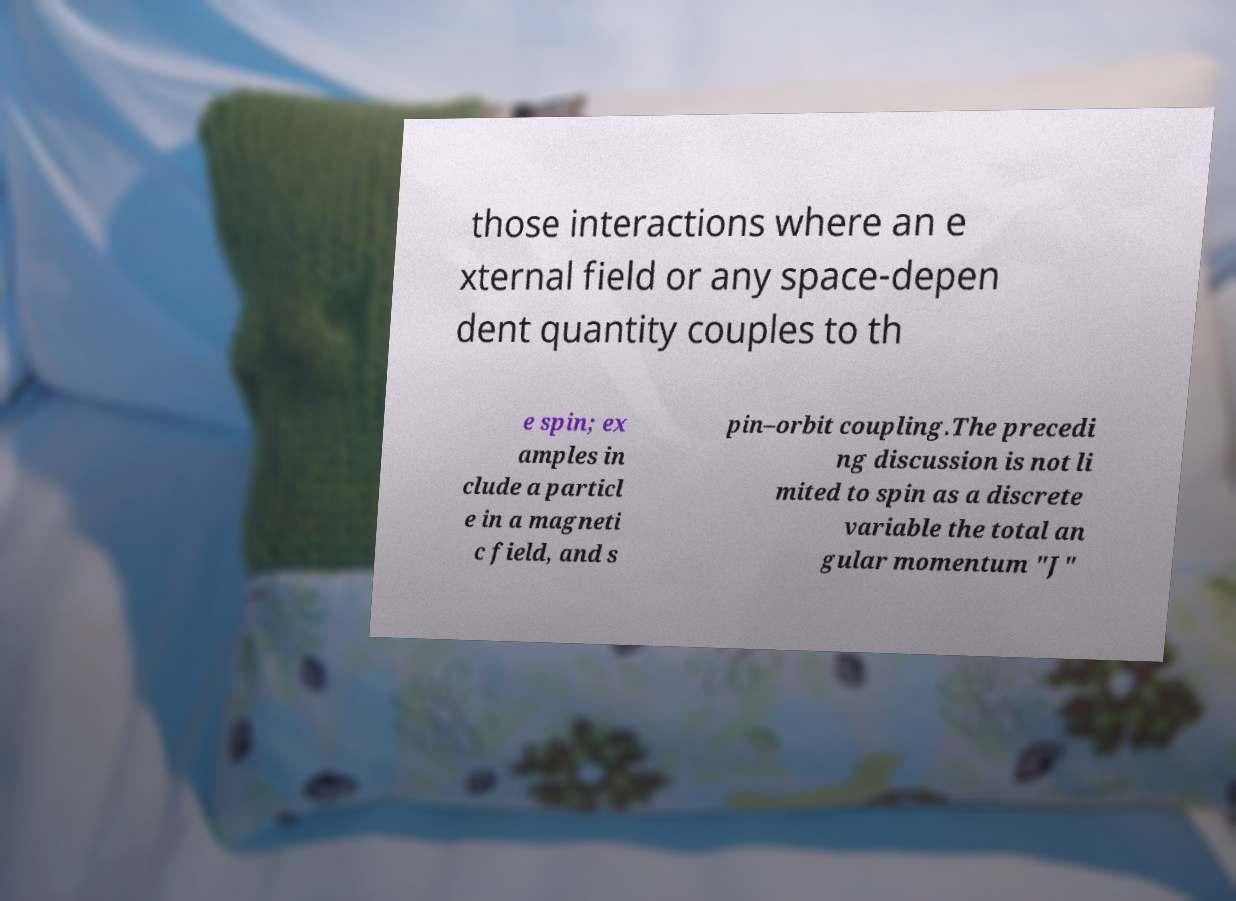Can you read and provide the text displayed in the image?This photo seems to have some interesting text. Can you extract and type it out for me? those interactions where an e xternal field or any space-depen dent quantity couples to th e spin; ex amples in clude a particl e in a magneti c field, and s pin–orbit coupling.The precedi ng discussion is not li mited to spin as a discrete variable the total an gular momentum "J" 